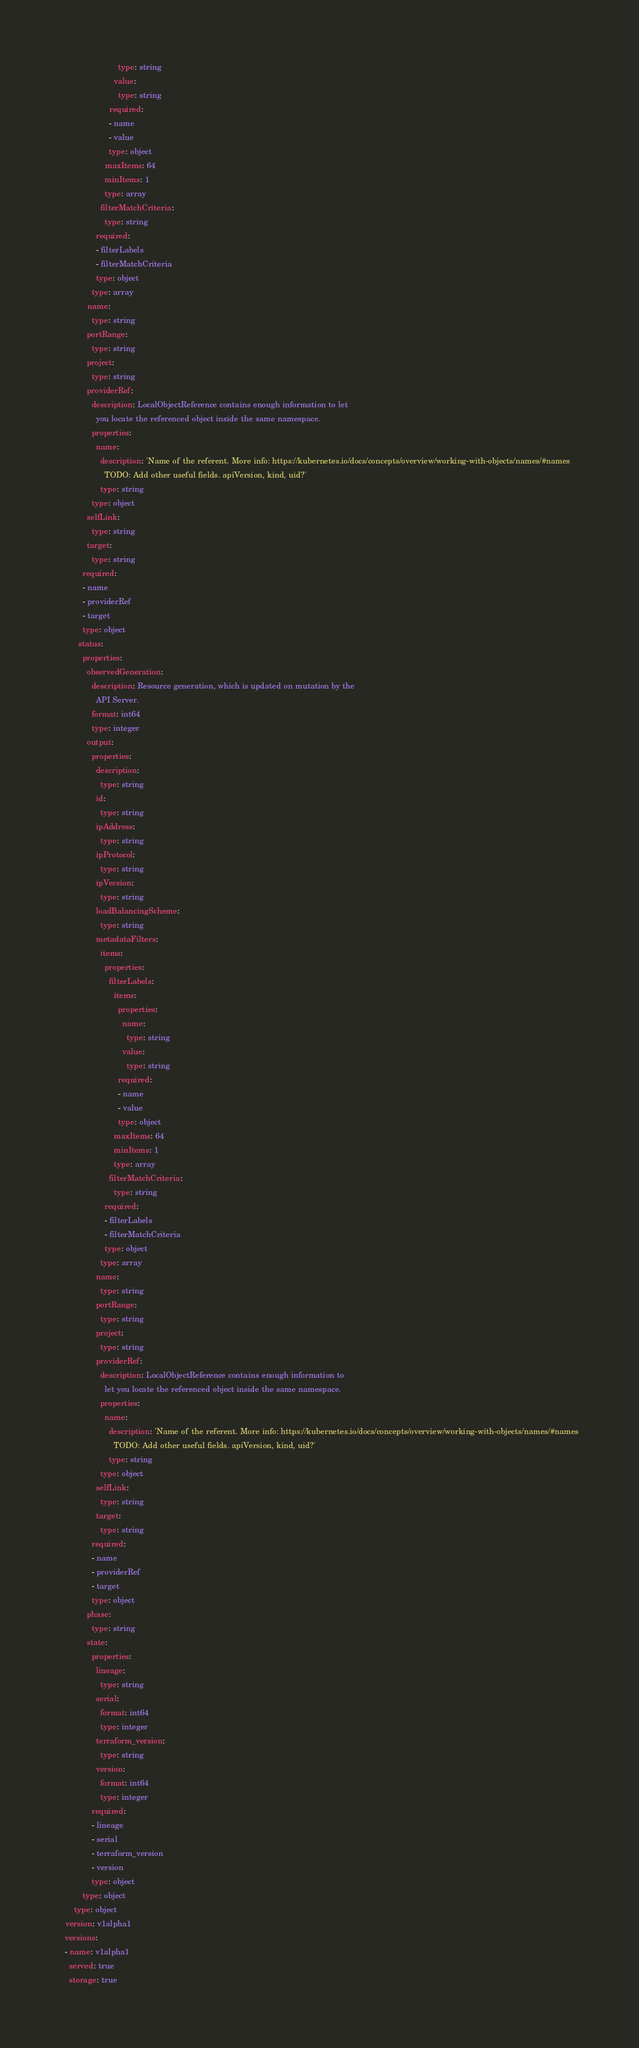Convert code to text. <code><loc_0><loc_0><loc_500><loc_500><_YAML_>                          type: string
                        value:
                          type: string
                      required:
                      - name
                      - value
                      type: object
                    maxItems: 64
                    minItems: 1
                    type: array
                  filterMatchCriteria:
                    type: string
                required:
                - filterLabels
                - filterMatchCriteria
                type: object
              type: array
            name:
              type: string
            portRange:
              type: string
            project:
              type: string
            providerRef:
              description: LocalObjectReference contains enough information to let
                you locate the referenced object inside the same namespace.
              properties:
                name:
                  description: 'Name of the referent. More info: https://kubernetes.io/docs/concepts/overview/working-with-objects/names/#names
                    TODO: Add other useful fields. apiVersion, kind, uid?'
                  type: string
              type: object
            selfLink:
              type: string
            target:
              type: string
          required:
          - name
          - providerRef
          - target
          type: object
        status:
          properties:
            observedGeneration:
              description: Resource generation, which is updated on mutation by the
                API Server.
              format: int64
              type: integer
            output:
              properties:
                description:
                  type: string
                id:
                  type: string
                ipAddress:
                  type: string
                ipProtocol:
                  type: string
                ipVersion:
                  type: string
                loadBalancingScheme:
                  type: string
                metadataFilters:
                  items:
                    properties:
                      filterLabels:
                        items:
                          properties:
                            name:
                              type: string
                            value:
                              type: string
                          required:
                          - name
                          - value
                          type: object
                        maxItems: 64
                        minItems: 1
                        type: array
                      filterMatchCriteria:
                        type: string
                    required:
                    - filterLabels
                    - filterMatchCriteria
                    type: object
                  type: array
                name:
                  type: string
                portRange:
                  type: string
                project:
                  type: string
                providerRef:
                  description: LocalObjectReference contains enough information to
                    let you locate the referenced object inside the same namespace.
                  properties:
                    name:
                      description: 'Name of the referent. More info: https://kubernetes.io/docs/concepts/overview/working-with-objects/names/#names
                        TODO: Add other useful fields. apiVersion, kind, uid?'
                      type: string
                  type: object
                selfLink:
                  type: string
                target:
                  type: string
              required:
              - name
              - providerRef
              - target
              type: object
            phase:
              type: string
            state:
              properties:
                lineage:
                  type: string
                serial:
                  format: int64
                  type: integer
                terraform_version:
                  type: string
                version:
                  format: int64
                  type: integer
              required:
              - lineage
              - serial
              - terraform_version
              - version
              type: object
          type: object
      type: object
  version: v1alpha1
  versions:
  - name: v1alpha1
    served: true
    storage: true
</code> 